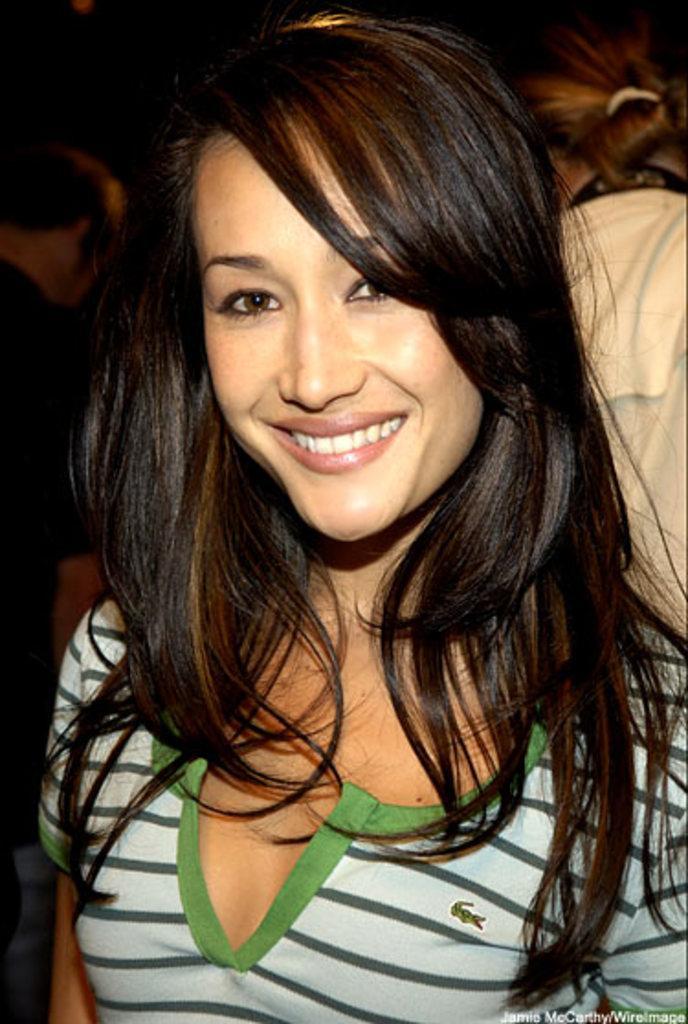In one or two sentences, can you explain what this image depicts? In this image in the foreground there is one woman who is smiling, and in the background there are some people. 